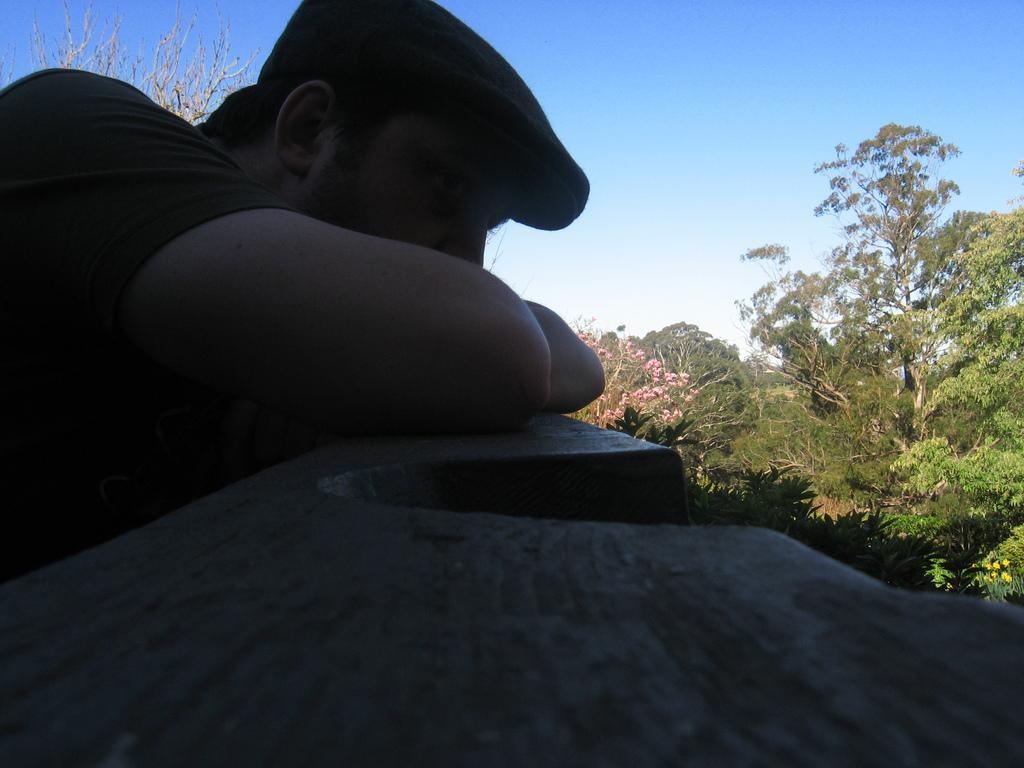What is the main subject of the image? There is a man standing in the image. Can you describe the man's attire? The man is wearing a hat. What type of vegetation can be seen on the right side of the image? There are green color trees on the right side of the image. What is the color of the sky in the image? The sky is blue in color and visible at the top of the image. Can you tell me how many girls are walking on the bridge in the image? There is no bridge or girl present in the image; it features a man standing with green trees and a blue sky. What type of organization is depicted in the image? There is no organization depicted in the image; it features a man standing with green trees and a blue sky. 